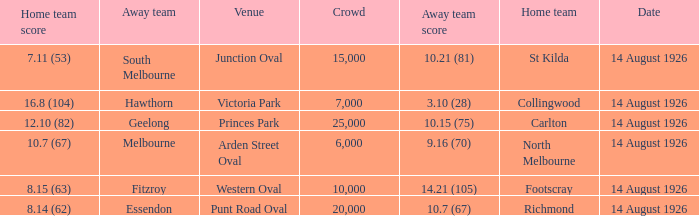Would you mind parsing the complete table? {'header': ['Home team score', 'Away team', 'Venue', 'Crowd', 'Away team score', 'Home team', 'Date'], 'rows': [['7.11 (53)', 'South Melbourne', 'Junction Oval', '15,000', '10.21 (81)', 'St Kilda', '14 August 1926'], ['16.8 (104)', 'Hawthorn', 'Victoria Park', '7,000', '3.10 (28)', 'Collingwood', '14 August 1926'], ['12.10 (82)', 'Geelong', 'Princes Park', '25,000', '10.15 (75)', 'Carlton', '14 August 1926'], ['10.7 (67)', 'Melbourne', 'Arden Street Oval', '6,000', '9.16 (70)', 'North Melbourne', '14 August 1926'], ['8.15 (63)', 'Fitzroy', 'Western Oval', '10,000', '14.21 (105)', 'Footscray', '14 August 1926'], ['8.14 (62)', 'Essendon', 'Punt Road Oval', '20,000', '10.7 (67)', 'Richmond', '14 August 1926']]} What was the crowd size at Victoria Park? 7000.0. 